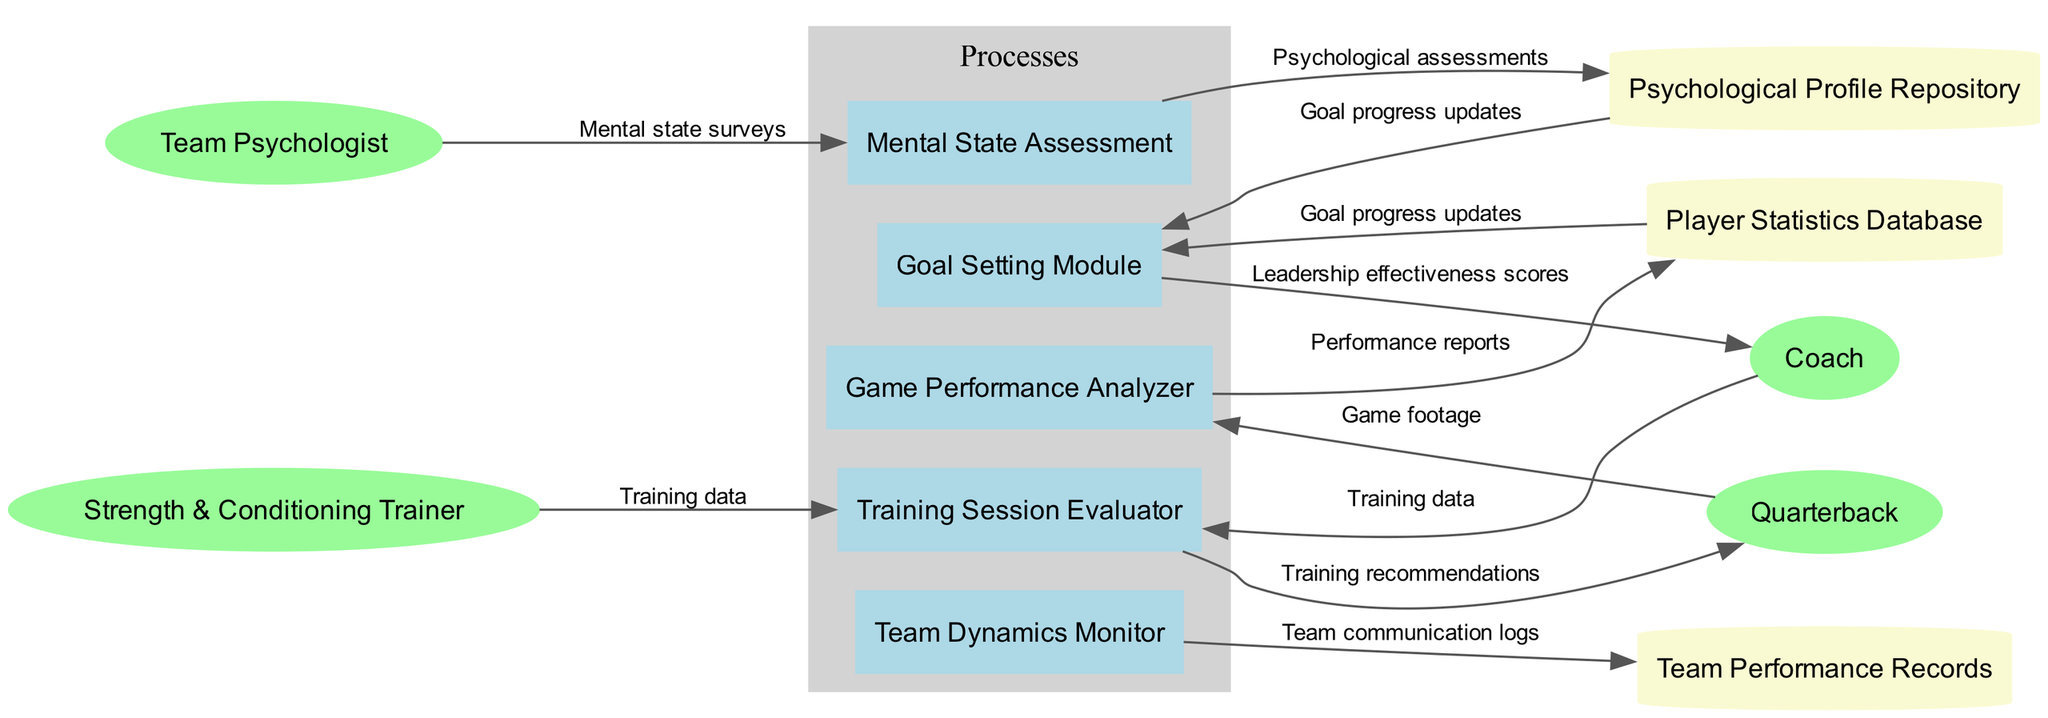What are the names of the processes in the diagram? The diagram lists five processes: Game Performance Analyzer, Training Session Evaluator, Mental State Assessment, Team Dynamics Monitor, and Goal Setting Module.
Answer: Game Performance Analyzer, Training Session Evaluator, Mental State Assessment, Team Dynamics Monitor, Goal Setting Module Which external entity is linked to the Training Session Evaluator process? The Training Session Evaluator process is connected to the Strength & Conditioning Trainer external entity, indicated by the data flow labeled "Training data."
Answer: Strength & Conditioning Trainer How many data stores are present in the diagram? There are three data stores indicated in the diagram, which are Player Statistics Database, Psychological Profile Repository, and Team Performance Records.
Answer: 3 What data flow connects the Game Performance Analyzer to the Player Statistics Database? The data flow labeled "Performance reports" connects the Game Performance Analyzer process to the Player Statistics Database data store, as shown in the diagram.
Answer: Performance reports Which process receives input from the Mental state surveys? The Mental state surveys flow into the Mental State Assessment process, which collects this input for analysis.
Answer: Mental State Assessment What type of information is represented by the node labeled "Psychological assessments"? The node labeled "Psychological assessments" represents data that comes from the Mental State Assessment process and is then stored in the Psychological Profile Repository data store.
Answer: Psychological assessments Which external entity receives output from the Goal Setting Module? The Goal Setting Module provides output data, specifically "Goal progress updates," to the Coach external entity within the diagram.
Answer: Coach What is the label of the data flow between the Team Psychologist and the Mental State Assessment process? The data flow connecting the Team Psychologist to the Mental State Assessment process is labeled "Mental state surveys," indicating the input given by the external entity.
Answer: Mental state surveys What is the primary purpose of the Goal Setting Module? The Goal Setting Module is designed to process inputs related to players' performance and set goals, resulting in updates that are shared with the Coach.
Answer: To set goals 